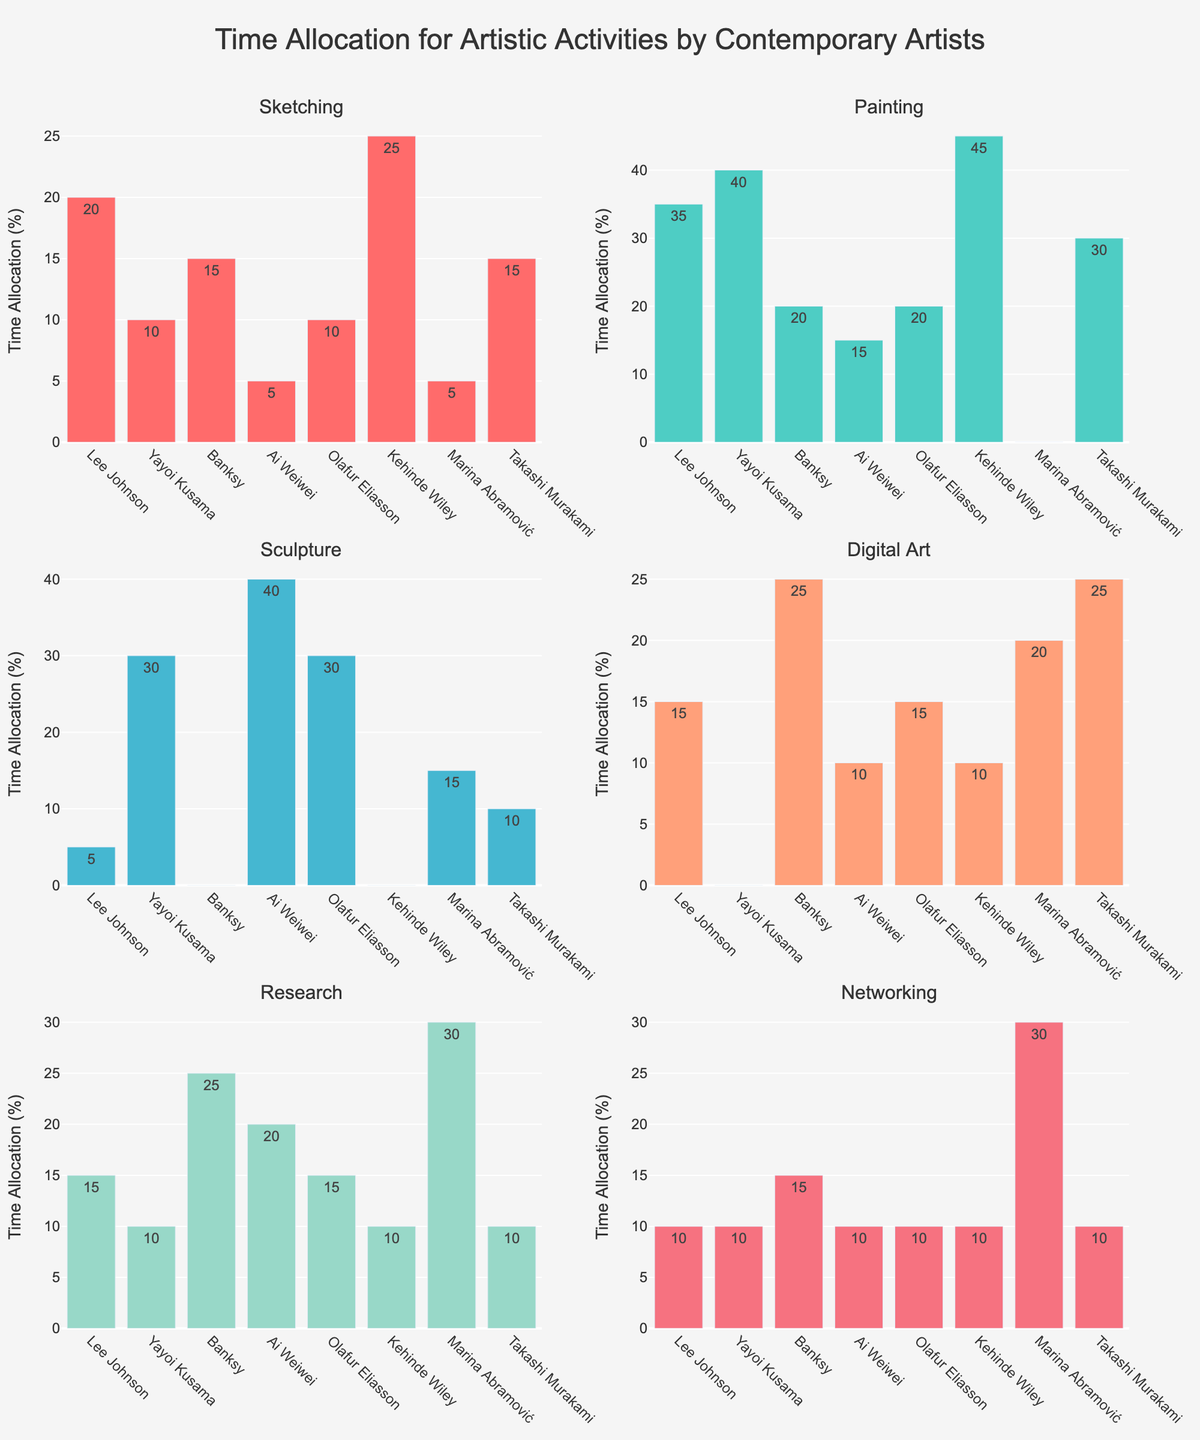What is the title of the figure? The title is usually located at the top of the figure. In this case, it says "Time Allocation for Artistic Activities by Contemporary Artists".
Answer: Time Allocation for Artistic Activities by Contemporary Artists How many artists are represented in the figure? Each subplot has bars representing different artists. Counting the bars in any subplot will reveal the number of artists represented.
Answer: 8 Which artist allocates the most time to Painting? To find this, locate the "Painting" subplot and identify the bar with the highest value. The artist with the highest bar in this subplot is Kehinde Wiley.
Answer: Kehinde Wiley What is the combined time allocation for Sketching and Networking by Banksy? Locate Banksy’s allocation in the "Sketching" and "Networking" subplots. Add 15 (Sketching) and 15 (Networking) to get the total.
Answer: 30 Who allocates more time to Research, Ai Weiwei or Marina Abramović? Compare the "Research" bar values for Ai Weiwei and Marina Abramović. Ai Weiwei has a higher value of 20 compared to Marina's 30.
Answer: Marina Abramović What is the average time allocation for Digital Art across all artists? Sum the values of "Digital Art" for all artists and divide by the number of artists (15 + 0 + 25 + 10 + 15 + 10 + 20 + 25 = 120; 120 / 8 = 15).
Answer: 15 Which artistic activity has the highest cumulative time allocation among all artists? Add the values of each activity across all artists. The activity with the highest sum is Painting (35 + 40 + 20 + 15 + 20 + 45 + 0 + 30 = 205).
Answer: Painting Who allocates zero time to one of the activities? Identify which bars have a value of zero in any subplot. Yayoi Kusama (Digital Art), Banksy (Sculpture), Kehinde Wiley (Sculpture), and Marina Abramović (Painting).
Answer: Yayoi Kusama, Banksy, Kehinde Wiley, Marina Abramović Which artist overall has the most varied (most types of activities) time allocation? The artist with non-zero bars in the most subplots likely has the most varied allocation. For instance, both Ai Weiwei and Olafur Eliasson engage in all activities.
Answer: Ai Weiwei, Olafur Eliasson What is the minimum time allocated for Sculpture among artists who spend time on it? Look at the subplots for Sculpture and identify the bars with non-zero values, then find the smallest value. The minimum is 5 (Lee Johnson).
Answer: 5 